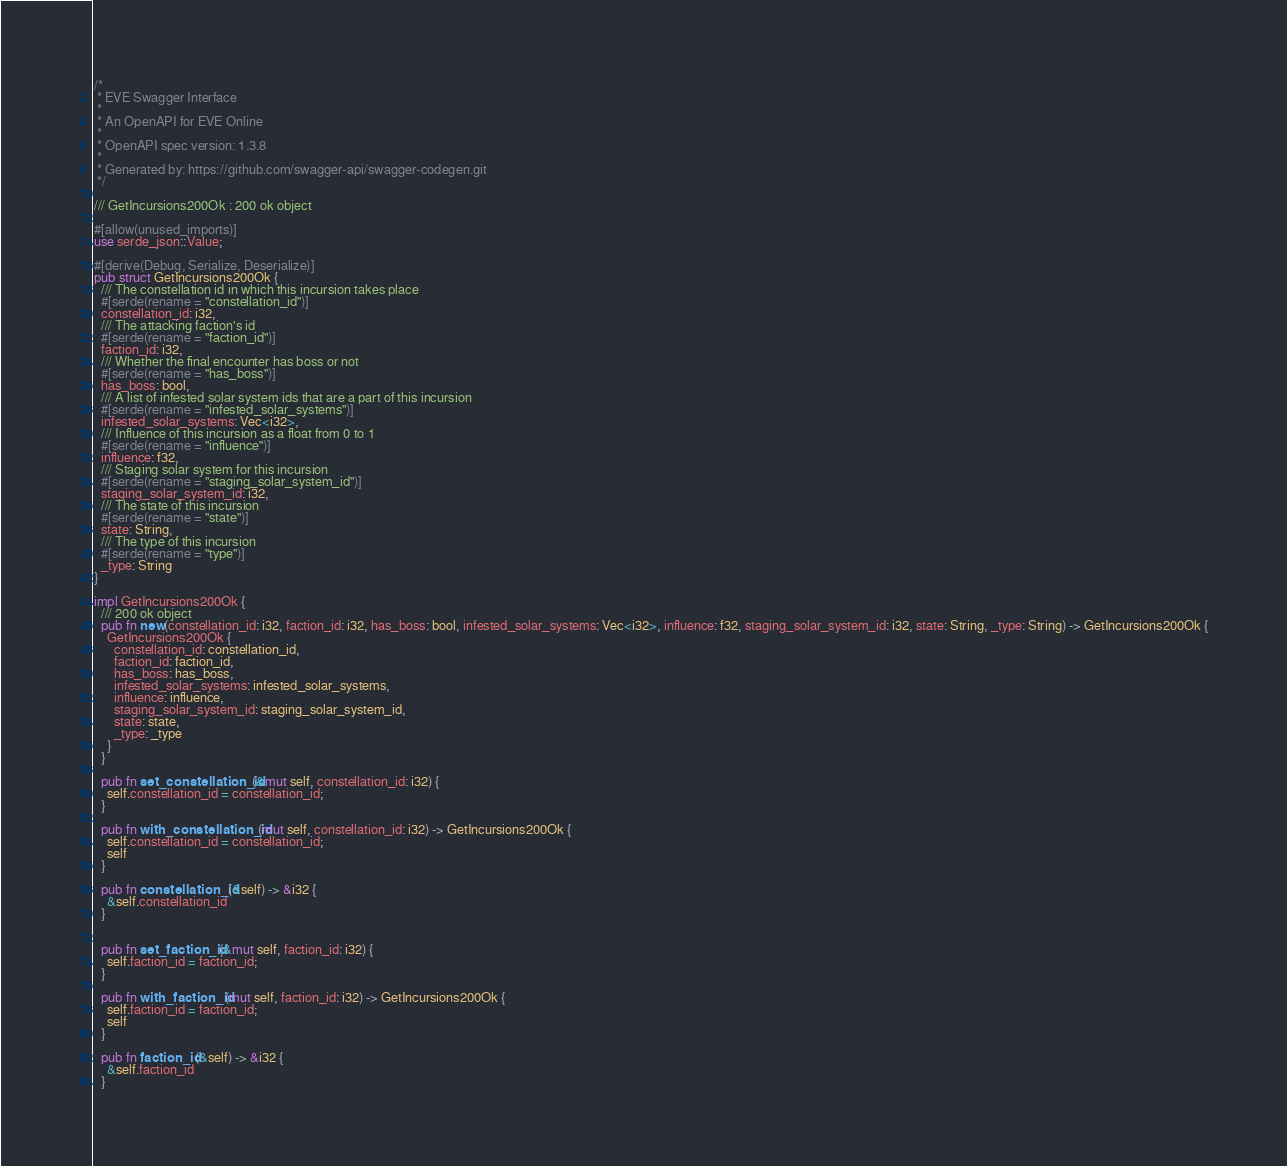Convert code to text. <code><loc_0><loc_0><loc_500><loc_500><_Rust_>/* 
 * EVE Swagger Interface
 *
 * An OpenAPI for EVE Online
 *
 * OpenAPI spec version: 1.3.8
 * 
 * Generated by: https://github.com/swagger-api/swagger-codegen.git
 */

/// GetIncursions200Ok : 200 ok object

#[allow(unused_imports)]
use serde_json::Value;

#[derive(Debug, Serialize, Deserialize)]
pub struct GetIncursions200Ok {
  /// The constellation id in which this incursion takes place
  #[serde(rename = "constellation_id")]
  constellation_id: i32,
  /// The attacking faction's id
  #[serde(rename = "faction_id")]
  faction_id: i32,
  /// Whether the final encounter has boss or not
  #[serde(rename = "has_boss")]
  has_boss: bool,
  /// A list of infested solar system ids that are a part of this incursion
  #[serde(rename = "infested_solar_systems")]
  infested_solar_systems: Vec<i32>,
  /// Influence of this incursion as a float from 0 to 1
  #[serde(rename = "influence")]
  influence: f32,
  /// Staging solar system for this incursion
  #[serde(rename = "staging_solar_system_id")]
  staging_solar_system_id: i32,
  /// The state of this incursion
  #[serde(rename = "state")]
  state: String,
  /// The type of this incursion
  #[serde(rename = "type")]
  _type: String
}

impl GetIncursions200Ok {
  /// 200 ok object
  pub fn new(constellation_id: i32, faction_id: i32, has_boss: bool, infested_solar_systems: Vec<i32>, influence: f32, staging_solar_system_id: i32, state: String, _type: String) -> GetIncursions200Ok {
    GetIncursions200Ok {
      constellation_id: constellation_id,
      faction_id: faction_id,
      has_boss: has_boss,
      infested_solar_systems: infested_solar_systems,
      influence: influence,
      staging_solar_system_id: staging_solar_system_id,
      state: state,
      _type: _type
    }
  }

  pub fn set_constellation_id(&mut self, constellation_id: i32) {
    self.constellation_id = constellation_id;
  }

  pub fn with_constellation_id(mut self, constellation_id: i32) -> GetIncursions200Ok {
    self.constellation_id = constellation_id;
    self
  }

  pub fn constellation_id(&self) -> &i32 {
    &self.constellation_id
  }


  pub fn set_faction_id(&mut self, faction_id: i32) {
    self.faction_id = faction_id;
  }

  pub fn with_faction_id(mut self, faction_id: i32) -> GetIncursions200Ok {
    self.faction_id = faction_id;
    self
  }

  pub fn faction_id(&self) -> &i32 {
    &self.faction_id
  }

</code> 